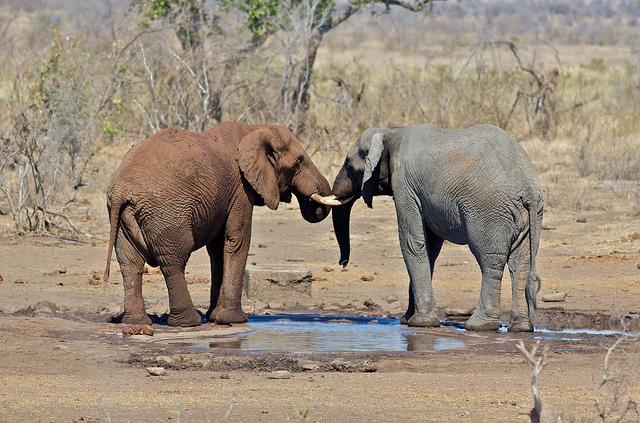Do all of the elephants have tusks?
Short answer required. Yes. Could this be on a river?
Write a very short answer. No. Are the elephants hungry?
Write a very short answer. No. Are the elephants both the same color?
Short answer required. No. Are they standing in a mud puddle?
Keep it brief. Yes. What body part will the elephants use to drink the water?
Give a very brief answer. Trunk. Where are the elephants standing?
Keep it brief. Mud. Are the elephants wet?
Quick response, please. No. 